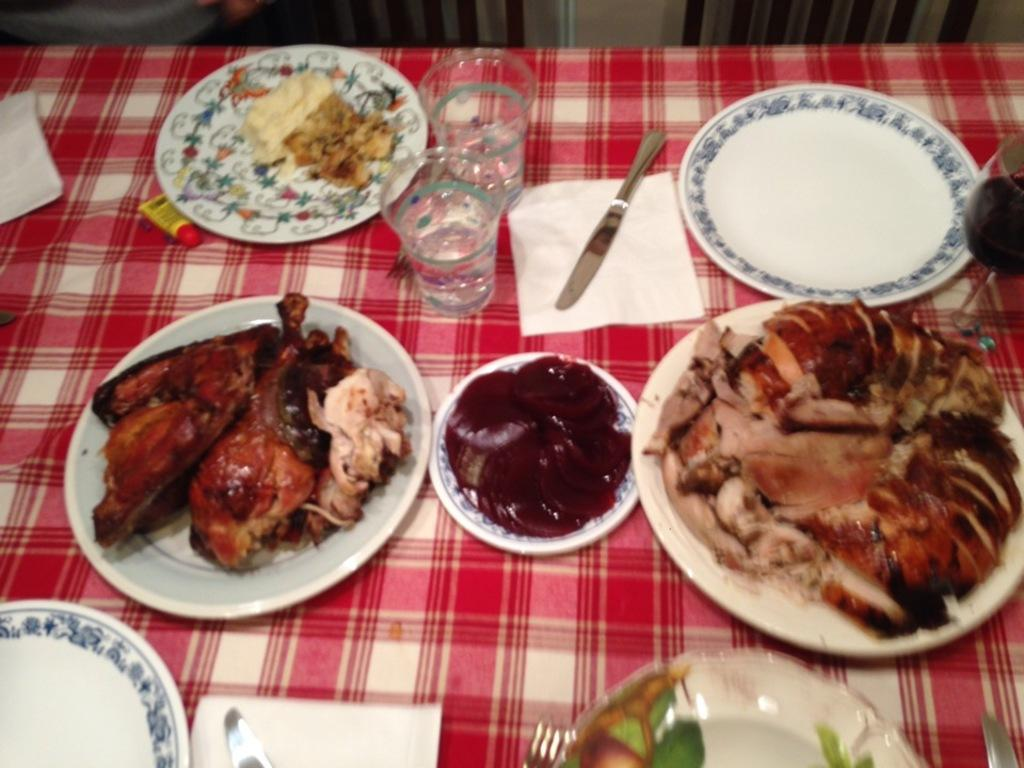What is the main piece of furniture in the image? There is a table in the image. What is covering the table? The table is covered with a red cloth. How many plates are on the table? There are many plates on the table. What else can be found on the table besides plates? Food, a knife, and glasses are present on the table. What language is being spoken by the can in the image? There is no can present in the image, and therefore no language being spoken by it. 